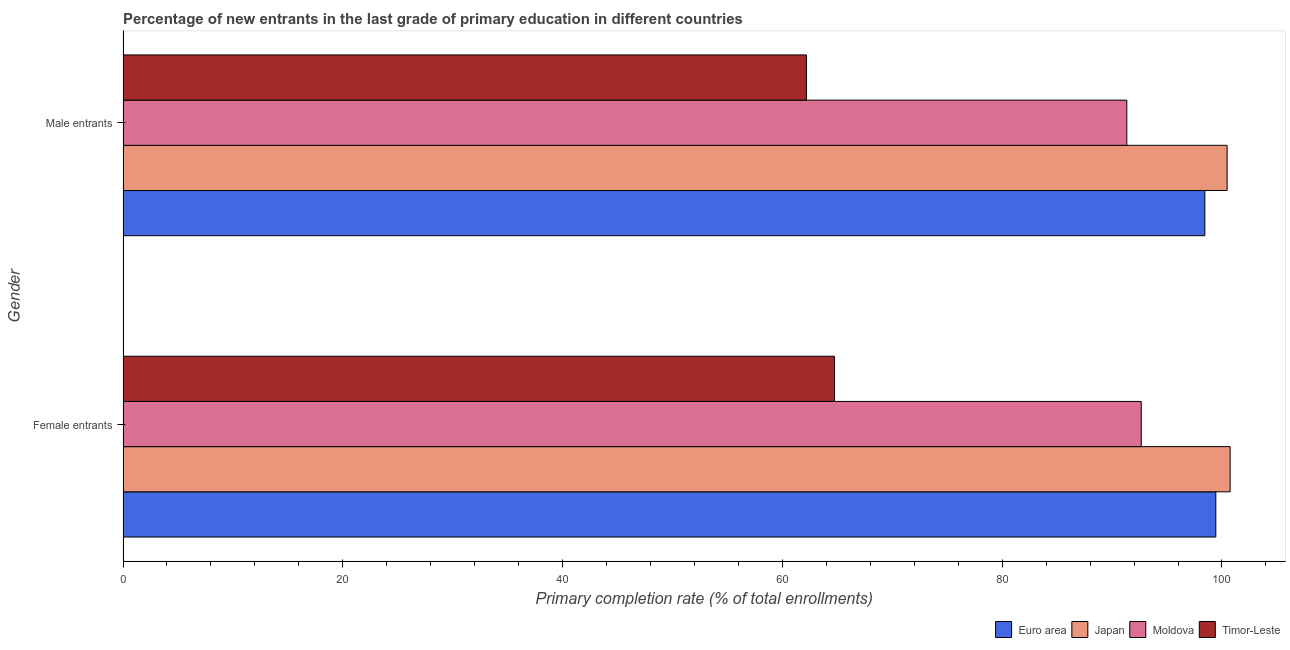How many groups of bars are there?
Make the answer very short. 2. Are the number of bars per tick equal to the number of legend labels?
Offer a very short reply. Yes. What is the label of the 1st group of bars from the top?
Provide a short and direct response. Male entrants. What is the primary completion rate of female entrants in Timor-Leste?
Ensure brevity in your answer.  64.74. Across all countries, what is the maximum primary completion rate of female entrants?
Ensure brevity in your answer.  100.74. Across all countries, what is the minimum primary completion rate of male entrants?
Your answer should be compact. 62.19. In which country was the primary completion rate of female entrants maximum?
Keep it short and to the point. Japan. In which country was the primary completion rate of female entrants minimum?
Your response must be concise. Timor-Leste. What is the total primary completion rate of male entrants in the graph?
Your response must be concise. 352.44. What is the difference between the primary completion rate of female entrants in Japan and that in Euro area?
Offer a terse response. 1.3. What is the difference between the primary completion rate of male entrants in Moldova and the primary completion rate of female entrants in Japan?
Make the answer very short. -9.4. What is the average primary completion rate of female entrants per country?
Give a very brief answer. 89.39. What is the difference between the primary completion rate of male entrants and primary completion rate of female entrants in Euro area?
Your answer should be compact. -1. What is the ratio of the primary completion rate of male entrants in Japan to that in Moldova?
Your answer should be compact. 1.1. Is the primary completion rate of female entrants in Moldova less than that in Euro area?
Offer a very short reply. Yes. What does the 1st bar from the top in Male entrants represents?
Your response must be concise. Timor-Leste. What does the 1st bar from the bottom in Male entrants represents?
Your answer should be very brief. Euro area. Are all the bars in the graph horizontal?
Your answer should be very brief. Yes. How many countries are there in the graph?
Make the answer very short. 4. Does the graph contain any zero values?
Provide a succinct answer. No. Does the graph contain grids?
Provide a succinct answer. No. What is the title of the graph?
Make the answer very short. Percentage of new entrants in the last grade of primary education in different countries. Does "Upper middle income" appear as one of the legend labels in the graph?
Give a very brief answer. No. What is the label or title of the X-axis?
Offer a terse response. Primary completion rate (% of total enrollments). What is the Primary completion rate (% of total enrollments) in Euro area in Female entrants?
Your answer should be compact. 99.44. What is the Primary completion rate (% of total enrollments) of Japan in Female entrants?
Offer a terse response. 100.74. What is the Primary completion rate (% of total enrollments) of Moldova in Female entrants?
Make the answer very short. 92.65. What is the Primary completion rate (% of total enrollments) of Timor-Leste in Female entrants?
Make the answer very short. 64.74. What is the Primary completion rate (% of total enrollments) in Euro area in Male entrants?
Ensure brevity in your answer.  98.44. What is the Primary completion rate (% of total enrollments) of Japan in Male entrants?
Offer a terse response. 100.47. What is the Primary completion rate (% of total enrollments) in Moldova in Male entrants?
Offer a terse response. 91.34. What is the Primary completion rate (% of total enrollments) of Timor-Leste in Male entrants?
Ensure brevity in your answer.  62.19. Across all Gender, what is the maximum Primary completion rate (% of total enrollments) of Euro area?
Keep it short and to the point. 99.44. Across all Gender, what is the maximum Primary completion rate (% of total enrollments) of Japan?
Offer a terse response. 100.74. Across all Gender, what is the maximum Primary completion rate (% of total enrollments) of Moldova?
Provide a succinct answer. 92.65. Across all Gender, what is the maximum Primary completion rate (% of total enrollments) in Timor-Leste?
Offer a very short reply. 64.74. Across all Gender, what is the minimum Primary completion rate (% of total enrollments) of Euro area?
Make the answer very short. 98.44. Across all Gender, what is the minimum Primary completion rate (% of total enrollments) in Japan?
Your response must be concise. 100.47. Across all Gender, what is the minimum Primary completion rate (% of total enrollments) in Moldova?
Ensure brevity in your answer.  91.34. Across all Gender, what is the minimum Primary completion rate (% of total enrollments) of Timor-Leste?
Offer a very short reply. 62.19. What is the total Primary completion rate (% of total enrollments) of Euro area in the graph?
Provide a short and direct response. 197.88. What is the total Primary completion rate (% of total enrollments) in Japan in the graph?
Give a very brief answer. 201.21. What is the total Primary completion rate (% of total enrollments) of Moldova in the graph?
Keep it short and to the point. 183.99. What is the total Primary completion rate (% of total enrollments) of Timor-Leste in the graph?
Give a very brief answer. 126.93. What is the difference between the Primary completion rate (% of total enrollments) in Japan in Female entrants and that in Male entrants?
Give a very brief answer. 0.27. What is the difference between the Primary completion rate (% of total enrollments) in Moldova in Female entrants and that in Male entrants?
Make the answer very short. 1.31. What is the difference between the Primary completion rate (% of total enrollments) in Timor-Leste in Female entrants and that in Male entrants?
Your answer should be very brief. 2.55. What is the difference between the Primary completion rate (% of total enrollments) in Euro area in Female entrants and the Primary completion rate (% of total enrollments) in Japan in Male entrants?
Offer a terse response. -1.03. What is the difference between the Primary completion rate (% of total enrollments) of Euro area in Female entrants and the Primary completion rate (% of total enrollments) of Moldova in Male entrants?
Give a very brief answer. 8.1. What is the difference between the Primary completion rate (% of total enrollments) of Euro area in Female entrants and the Primary completion rate (% of total enrollments) of Timor-Leste in Male entrants?
Ensure brevity in your answer.  37.25. What is the difference between the Primary completion rate (% of total enrollments) of Japan in Female entrants and the Primary completion rate (% of total enrollments) of Moldova in Male entrants?
Ensure brevity in your answer.  9.4. What is the difference between the Primary completion rate (% of total enrollments) in Japan in Female entrants and the Primary completion rate (% of total enrollments) in Timor-Leste in Male entrants?
Provide a succinct answer. 38.55. What is the difference between the Primary completion rate (% of total enrollments) in Moldova in Female entrants and the Primary completion rate (% of total enrollments) in Timor-Leste in Male entrants?
Ensure brevity in your answer.  30.46. What is the average Primary completion rate (% of total enrollments) of Euro area per Gender?
Ensure brevity in your answer.  98.94. What is the average Primary completion rate (% of total enrollments) of Japan per Gender?
Keep it short and to the point. 100.6. What is the average Primary completion rate (% of total enrollments) of Moldova per Gender?
Your answer should be compact. 92. What is the average Primary completion rate (% of total enrollments) of Timor-Leste per Gender?
Offer a terse response. 63.46. What is the difference between the Primary completion rate (% of total enrollments) of Euro area and Primary completion rate (% of total enrollments) of Japan in Female entrants?
Give a very brief answer. -1.3. What is the difference between the Primary completion rate (% of total enrollments) of Euro area and Primary completion rate (% of total enrollments) of Moldova in Female entrants?
Your response must be concise. 6.79. What is the difference between the Primary completion rate (% of total enrollments) of Euro area and Primary completion rate (% of total enrollments) of Timor-Leste in Female entrants?
Your answer should be compact. 34.7. What is the difference between the Primary completion rate (% of total enrollments) of Japan and Primary completion rate (% of total enrollments) of Moldova in Female entrants?
Ensure brevity in your answer.  8.09. What is the difference between the Primary completion rate (% of total enrollments) in Japan and Primary completion rate (% of total enrollments) in Timor-Leste in Female entrants?
Provide a short and direct response. 36.01. What is the difference between the Primary completion rate (% of total enrollments) in Moldova and Primary completion rate (% of total enrollments) in Timor-Leste in Female entrants?
Keep it short and to the point. 27.92. What is the difference between the Primary completion rate (% of total enrollments) in Euro area and Primary completion rate (% of total enrollments) in Japan in Male entrants?
Your answer should be very brief. -2.03. What is the difference between the Primary completion rate (% of total enrollments) of Euro area and Primary completion rate (% of total enrollments) of Moldova in Male entrants?
Keep it short and to the point. 7.1. What is the difference between the Primary completion rate (% of total enrollments) of Euro area and Primary completion rate (% of total enrollments) of Timor-Leste in Male entrants?
Give a very brief answer. 36.25. What is the difference between the Primary completion rate (% of total enrollments) in Japan and Primary completion rate (% of total enrollments) in Moldova in Male entrants?
Provide a short and direct response. 9.13. What is the difference between the Primary completion rate (% of total enrollments) of Japan and Primary completion rate (% of total enrollments) of Timor-Leste in Male entrants?
Give a very brief answer. 38.28. What is the difference between the Primary completion rate (% of total enrollments) in Moldova and Primary completion rate (% of total enrollments) in Timor-Leste in Male entrants?
Offer a terse response. 29.15. What is the ratio of the Primary completion rate (% of total enrollments) of Japan in Female entrants to that in Male entrants?
Ensure brevity in your answer.  1. What is the ratio of the Primary completion rate (% of total enrollments) of Moldova in Female entrants to that in Male entrants?
Your response must be concise. 1.01. What is the ratio of the Primary completion rate (% of total enrollments) of Timor-Leste in Female entrants to that in Male entrants?
Your answer should be very brief. 1.04. What is the difference between the highest and the second highest Primary completion rate (% of total enrollments) in Japan?
Make the answer very short. 0.27. What is the difference between the highest and the second highest Primary completion rate (% of total enrollments) in Moldova?
Keep it short and to the point. 1.31. What is the difference between the highest and the second highest Primary completion rate (% of total enrollments) of Timor-Leste?
Provide a short and direct response. 2.55. What is the difference between the highest and the lowest Primary completion rate (% of total enrollments) of Euro area?
Provide a succinct answer. 1. What is the difference between the highest and the lowest Primary completion rate (% of total enrollments) of Japan?
Your response must be concise. 0.27. What is the difference between the highest and the lowest Primary completion rate (% of total enrollments) in Moldova?
Offer a terse response. 1.31. What is the difference between the highest and the lowest Primary completion rate (% of total enrollments) of Timor-Leste?
Make the answer very short. 2.55. 